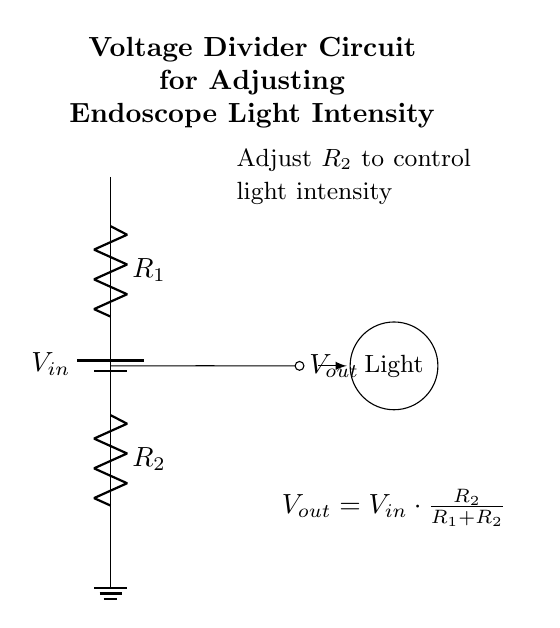What are the components of the circuit? The circuit consists of a battery, two resistors, and a light. The battery provides voltage, the resistors form a voltage divider, and the light is the output component.
Answer: battery, resistors, light What does \( V_{out} \) represent? \( V_{out} \) is the output voltage across resistor \( R_2 \). It indicates the voltage supplied to the endoscope light based on the resistor values.
Answer: output voltage What is the function of \( R_2 \)? \( R_2 \) is adjusted to control the light intensity by changing \( V_{out} \). It is key in the voltage divider formula to achieve desired output.
Answer: control light intensity If \( R_1 \) is doubled, how does \( V_{out} \) change? Doubling \( R_1 \) increases the total resistance \( (R_1 + R_2) \) while keeping \( R_2 \) constant, resulting in a decrease in \( V_{out} \) due to the formula \( V_{out} = V_{in} \cdot \frac{R_2}{R_1 + R_2} \).
Answer: decreases What is the relationship between \( V_{in} \) and \( R_2 \)? The output voltage \( V_{out} \) is directly proportional to \( V_{in} \) and the fraction \( \frac{R_2}{R_1 + R_2} \). As \( V_{in} \) increases, \( V_{out} \) increases if \( R_2 \) remains constant.
Answer: proportional increase What happens to the light if \( R_2 \) is set to zero? If \( R_2 \) is zero, the output voltage \( V_{out} \) will also be zero, meaning no current flows to the light. The light will be off because it receives no voltage.
Answer: light is off 